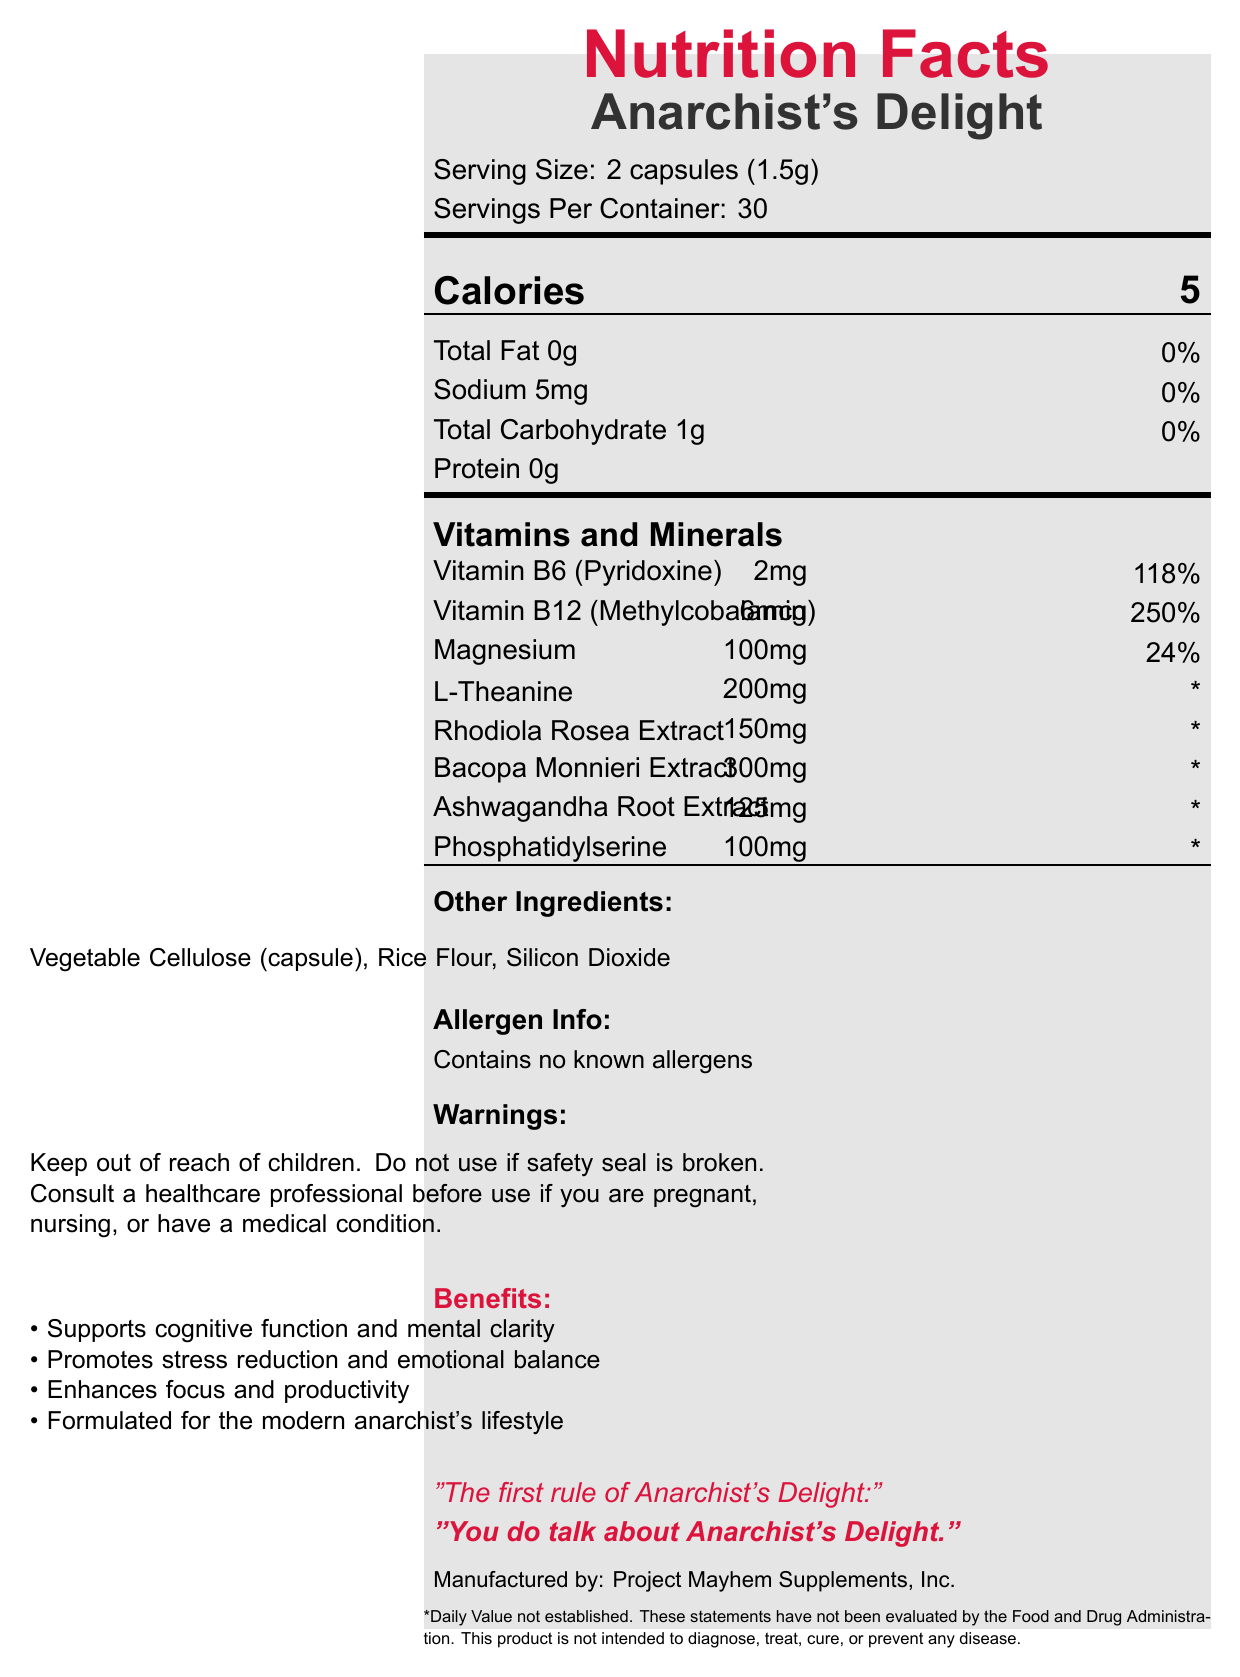what is the serving size of "Anarchist's Delight"? The serving size is mentioned right below the title in the serving information section.
Answer: 2 capsules (1.5g) how many capsules are there in one container of this supplement? Each serving size is 2 capsules and there are 30 servings per container; thus, 2 capsules * 30 servings = 60 capsules.
Answer: 60 capsules how many calories does one serving contain? The calorie count is listed in bold on the left under the calories section.
Answer: 5 which vitamin in "Anarchist's Delight" has the highest daily value percentage? Vitamin B12 has a daily value percentage of 250%, which is the highest listed.
Answer: Vitamin B12 (Methylcobalamin) does this supplement contain any allergens? The allergen information section states "Contains no known allergens."
Answer: No which of the following is not an ingredient in "Anarchist's Delight"? A. Silicon Dioxide B. Rice Flour C. Sugar D. Phosphatidylserine The list of other ingredients does not include sugar.
Answer: C what are the marketing claims made for this supplement? These claims are listed under the marketing claims section highlighted in anarchyred color.
Answer: Supports cognitive function and mental clarity, Promotes stress reduction and emotional balance, Enhances focus and productivity, Formulated for the modern anarchist's lifestyle which ingredient is present in the largest quantity? A. L-Theanine B. Bacopa Monnieri Extract C. Ashwagandha Root Extract D. Rhodiola Rosea Extract Bacopa Monnieri Extract is listed as 300mg, which is higher than the other ingredients listed.
Answer: B is the safety of this supplement guaranteed by the FDA? The disclaimer explicitly states that these statements have not been evaluated by the Food and Drug Administration.
Answer: No summarize the main benefits of consuming "Anarchist's Delight". This summary captures the key benefits listed in the marketing claims and the overall purpose of the supplement.
Answer: "Anarchist's Delight" is a vitamin supplement that supports cognitive function, stress reduction, focus, and productivity through its blend of vitamins, minerals, and plant extracts. It is marketed specifically for an anarchist's lifestyle. what is the percentage of daily value for magnesium provided by "Anarchist's Delight"? The daily value for magnesium is listed as 24% in the vitamins and minerals section.
Answer: 24% what is the tagline inspired by Fight Club? The tagline is provided at the end of the document in italic and bold text.
Answer: "The first rule of Anarchist's Delight: You do talk about Anarchist's Delight." is there silicon dioxide in this vitamin supplement? Silicon dioxide is listed among the other ingredients.
Answer: Yes what should you do if the safety seal is broken? This warning is clearly stated in the warnings section.
Answer: Do not use the product which ingredient listed does not have an established daily value? The daily values for these ingredients are marked with an asterisk, indicating that they are not established.
Answer: L-Theanine, Rhodiola Rosea Extract, Bacopa Monnieri Extract, Ashwagandha Root Extract, Phosphatidylserine what is the company's name that manufactures "Anarchist's Delight"? The manufacturing company is listed towards the end of the document.
Answer: Project Mayhem Supplements, Inc. what is the purpose of vegetable cellulose in this supplement? The document does not provide specific information on why vegetable cellulose is included in this supplement.
Answer: Not enough information 